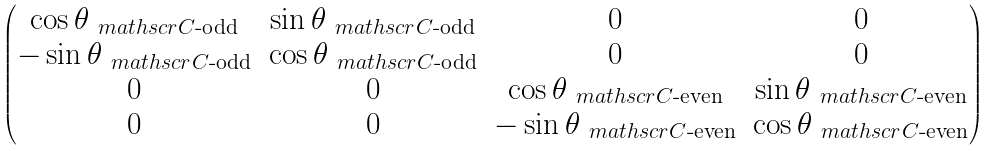<formula> <loc_0><loc_0><loc_500><loc_500>\begin{pmatrix} \cos \theta _ { \ m a t h s c r { C } \text {-odd} } & \sin \theta _ { \ m a t h s c r { C } \text {-odd} } & 0 & 0 \\ - \sin \theta _ { \ m a t h s c r { C } \text {-odd} } & \cos \theta _ { \ m a t h s c r { C } \text {-odd} } & 0 & 0 \\ 0 & 0 & \cos \theta _ { \ m a t h s c r { C } \text {-even} } & \sin \theta _ { \ m a t h s c r { C } \text {-even} } \\ 0 & 0 & - \sin \theta _ { \ m a t h s c r { C } \text {-even} } & \cos \theta _ { \ m a t h s c r { C } \text {-even} } \end{pmatrix}</formula> 